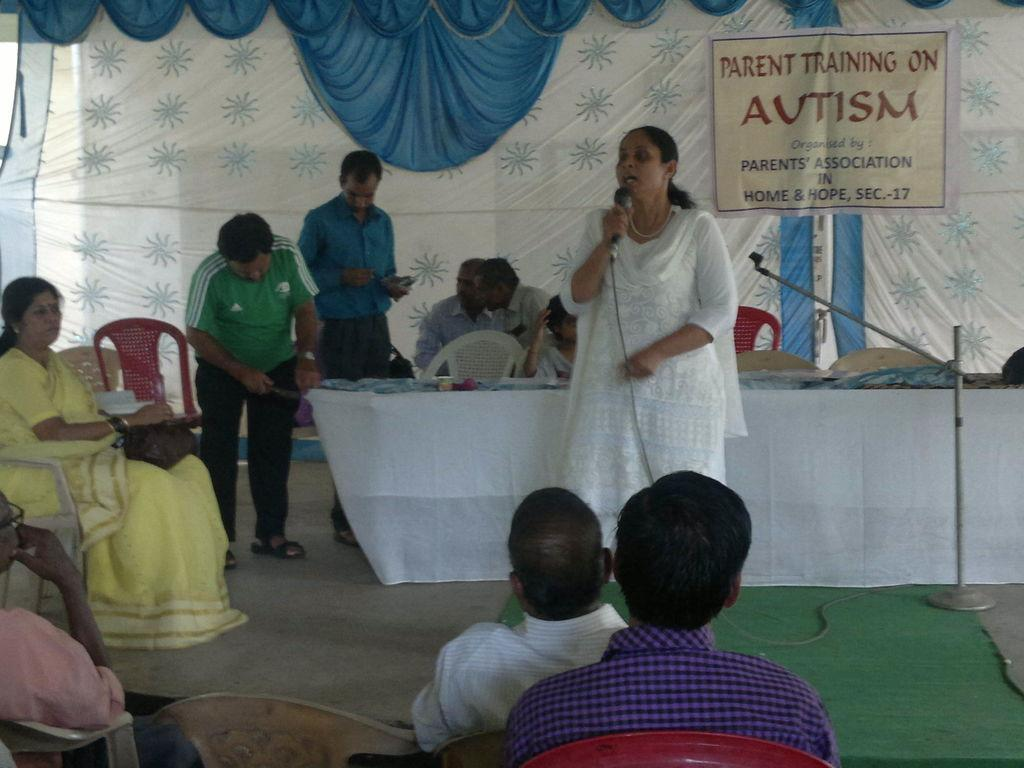Who or what can be seen in the image? There are people in the image. What furniture is present in the image? There are chairs and a table in the image. What decorative element is present in the image? There is a banner in the image. What type of material is visible in the image? There is cloth in the image. Can you describe the table setting in the image? There is a white cloth on the table in the image. What equipment is present in the image? There is a mic in the image. Reasoning: Let's think step by following the guidelines to produce the conversation. We start by identifying the main subjects and objects in the image based on the provided facts. We then formulate questions that focus on the location and characteristics of these subjects and objects, ensuring that each question can be answered definitively with the information given. We avoid yes/no questions and ensure that the language is simple and clear. Absurd Question/Answer: How many stomachs can be seen in the image? There are no stomachs visible in the image. What type of lace is draped over the chairs in the image? There is no lace present in the image. How many legs can be seen in the image? There is no specific mention of legs in the image, but we can see people, chairs, and a table, which all have legs. However, the question is considered "absurd" because it is not directly related to the given facts and is not a definitive question that can be answered based on the image. 